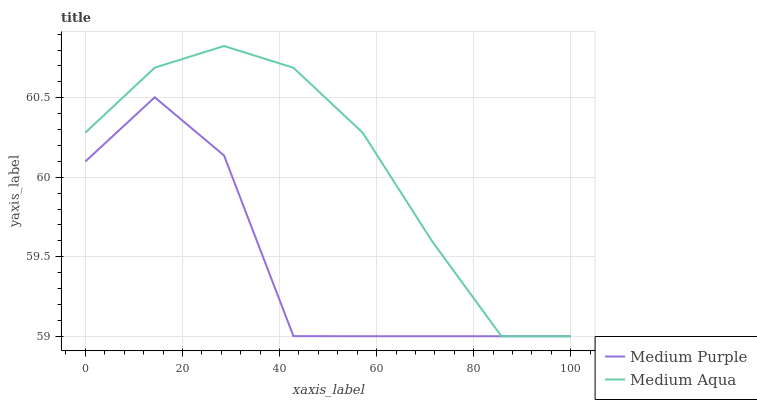Does Medium Purple have the minimum area under the curve?
Answer yes or no. Yes. Does Medium Aqua have the maximum area under the curve?
Answer yes or no. Yes. Does Medium Aqua have the minimum area under the curve?
Answer yes or no. No. Is Medium Aqua the smoothest?
Answer yes or no. Yes. Is Medium Purple the roughest?
Answer yes or no. Yes. Is Medium Aqua the roughest?
Answer yes or no. No. Does Medium Purple have the lowest value?
Answer yes or no. Yes. Does Medium Aqua have the highest value?
Answer yes or no. Yes. Does Medium Aqua intersect Medium Purple?
Answer yes or no. Yes. Is Medium Aqua less than Medium Purple?
Answer yes or no. No. Is Medium Aqua greater than Medium Purple?
Answer yes or no. No. 